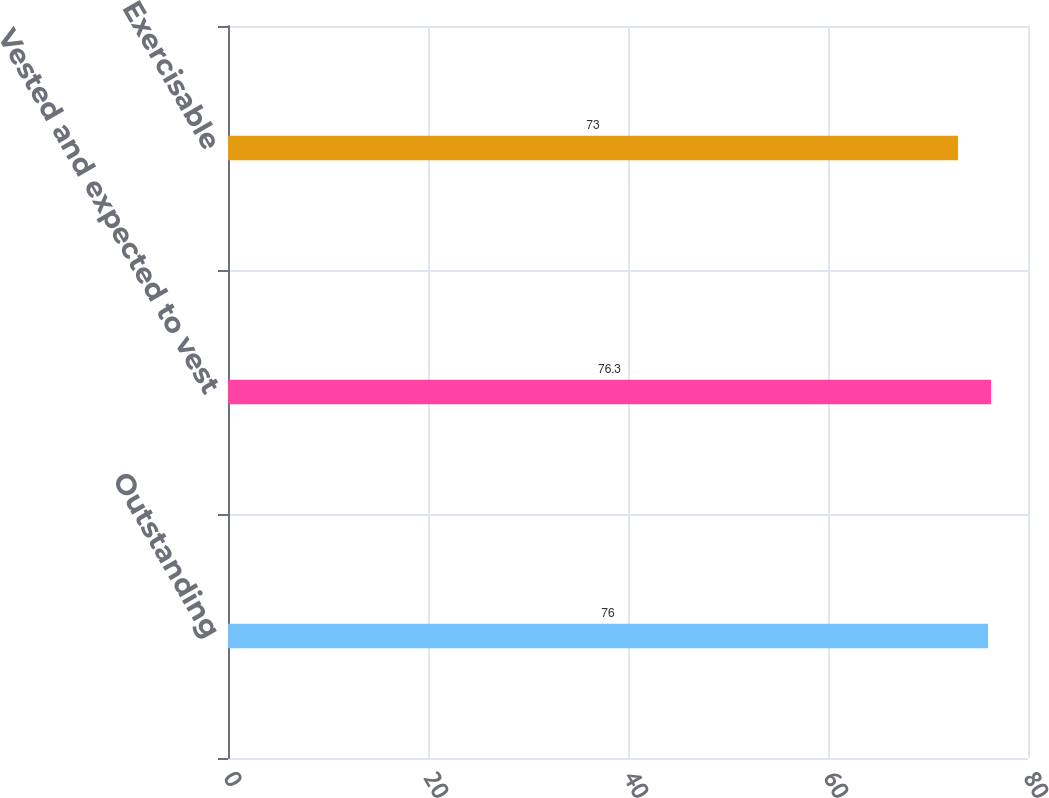<chart> <loc_0><loc_0><loc_500><loc_500><bar_chart><fcel>Outstanding<fcel>Vested and expected to vest<fcel>Exercisable<nl><fcel>76<fcel>76.3<fcel>73<nl></chart> 